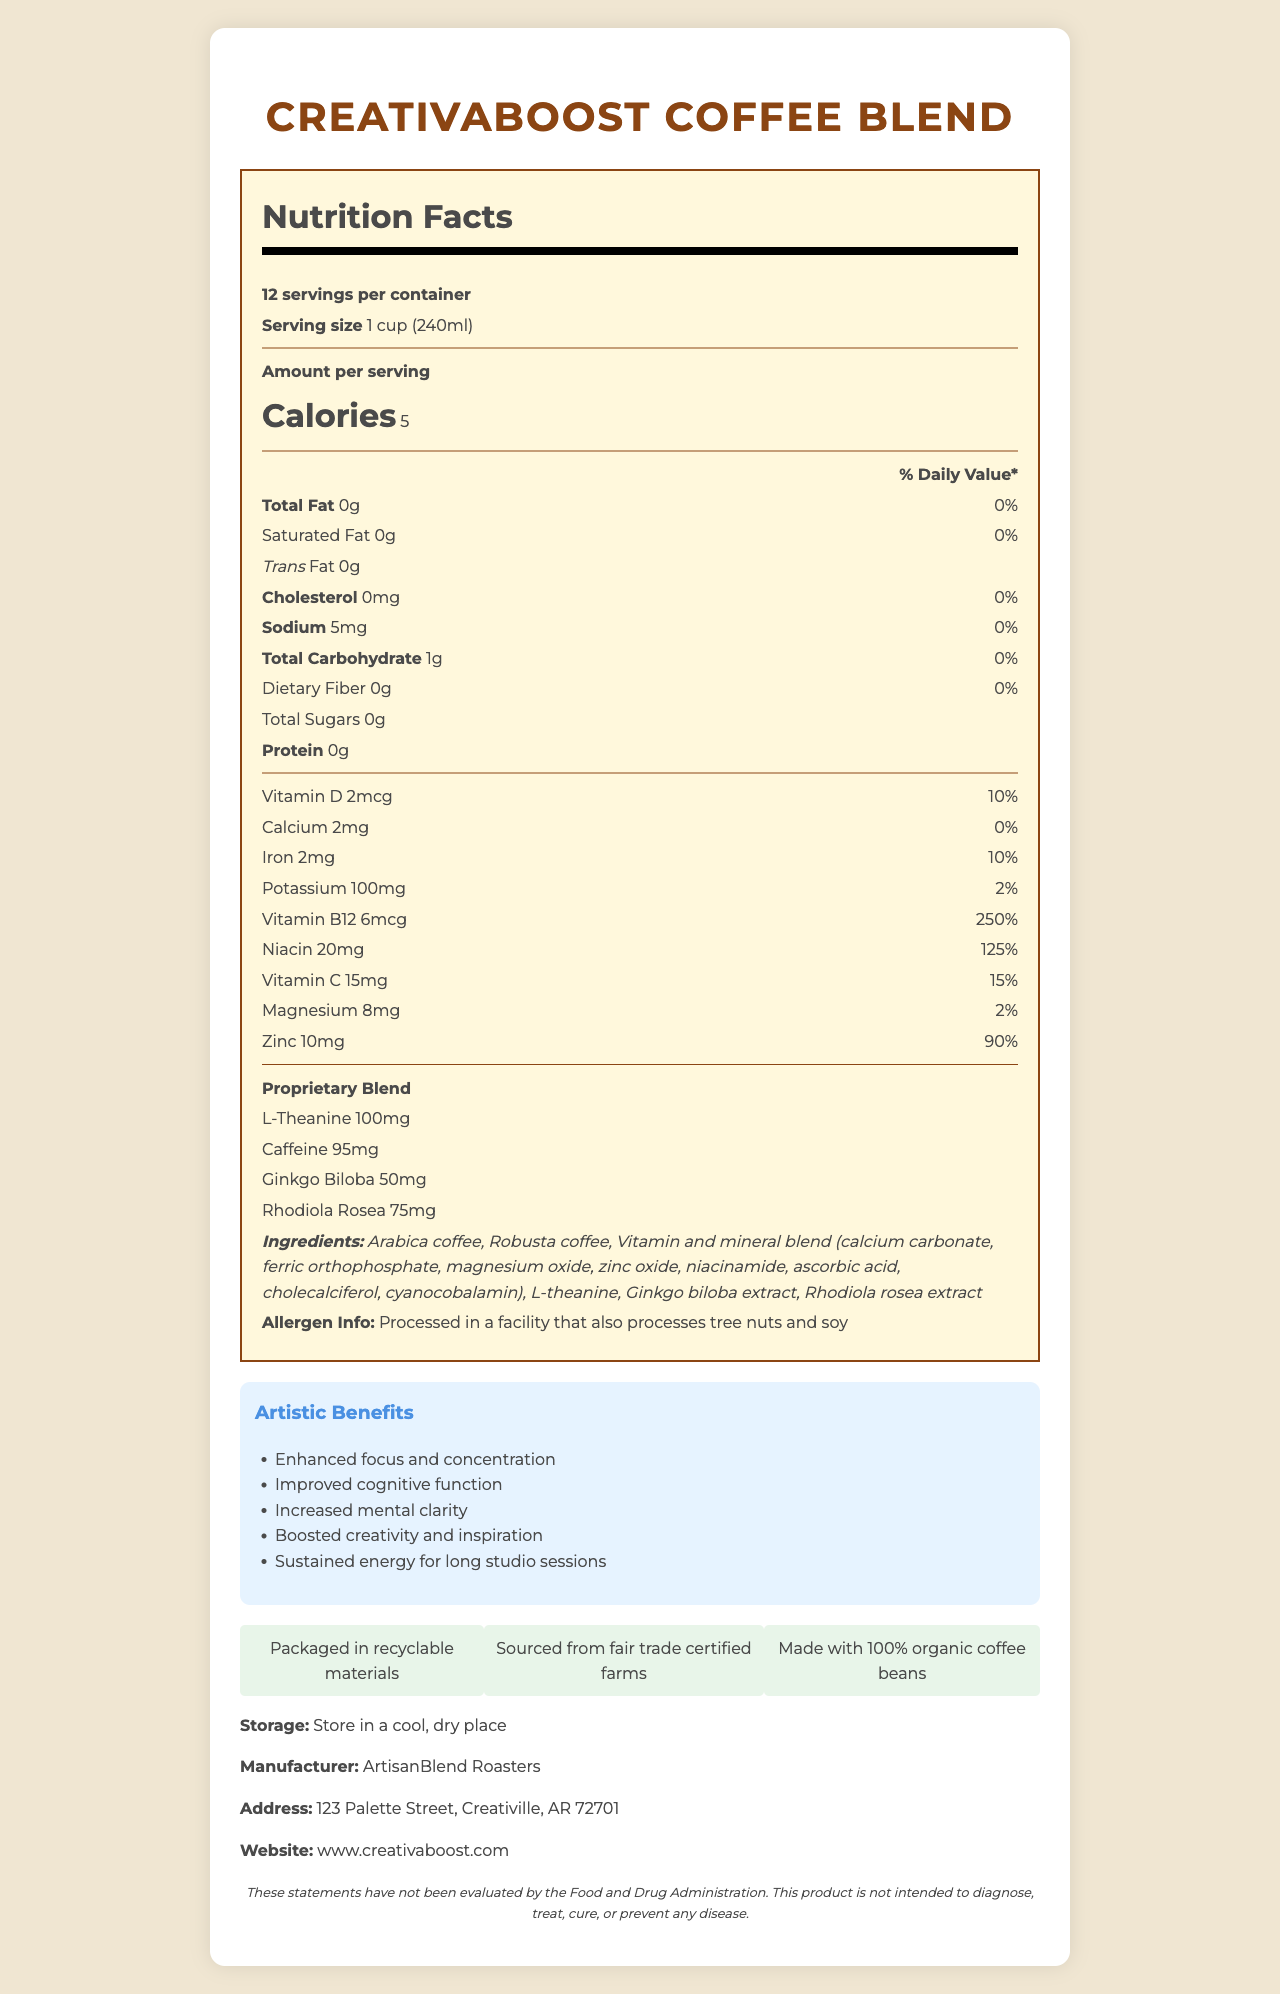what is the serving size for the CreativaBoost Coffee Blend? The serving size is explicitly mentioned as "1 cup (240ml)" in the document.
Answer: 1 cup (240ml) how many servings are in one container of CreativaBoost Coffee Blend? The document states that there are "12 servings per container".
Answer: 12 how much caffeine is in one serving of CreativaBoost Coffee Blend? The document lists 95mg of caffeine per serving in the Proprietary Blend section.
Answer: 95mg how many calories are there per serving? The document specifies that there are 5 calories per serving.
Answer: 5 how much sodium does one serving contain? The document specifies that one serving contains 5mg of sodium.
Answer: 5mg what are some of the artistic benefits mentioned for CreativaBoost Coffee Blend? These benefits are listed under the "Artistic Benefits" section of the document.
Answer: Enhanced focus and concentration, Improved cognitive function, Increased mental clarity, Boosted creativity and inspiration, Sustained energy for long studio sessions which company manufactures the CreativaBoost Coffee Blend? The document lists the manufacturer as "ArtisanBlend Roasters".
Answer: ArtisanBlend Roasters where should the CreativaBoost Coffee Blend be stored? The storage instructions indicate that it should be stored "in a cool, dry place".
Answer: Store in a cool, dry place does CreativaBoost Coffee Blend contain any tree nut or soy allergens? The allergen information states that it is processed in a facility that also processes tree nuts and soy.
Answer: Processed in a facility that also processes tree nuts and soy is CreativaBoost Coffee Blend made with organic coffee beans? The document mentions that the product is "made with 100% organic coffee beans".
Answer: Yes which mineral is NOT part of the vitamin and mineral blend? A. Calcium B. Iron C. Selenium The document lists calcium and iron but does not mention selenium.
Answer: C what percentage of daily value does one serving of Vitamin B12 provide? A. 50% B. 100% C. 250% The document specifies that one serving provides 250% of the daily value for Vitamin B12.
Answer: C which of the following is NOT listed as an ingredient in CreativaBoost Coffee Blend? A. Arabica coffee B. Omega-3 oil C. L-theanine Omega-3 oil is not listed as an ingredient in the document.
Answer: B is CreativaBoost Coffee Blend packaged in recyclable materials? The document states that it is "packaged in recyclable materials".
Answer: Yes what is the main idea of this document? The document includes detailed nutrition facts, lists of ingredients, artistic benefits, storage and manufacturer information, and additional eco-friendly and fair trade details.
Answer: The document provides nutritional information about the CreativaBoost Coffee Blend, highlighting its special ingredients, artistic benefits, storage instructions, and eco-friendly packaging. Which other products does ArtisanBlend Roasters offer? The document does not provide details about other products offered by ArtisanBlend Roasters.
Answer: Not enough information 